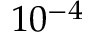<formula> <loc_0><loc_0><loc_500><loc_500>1 0 ^ { - 4 }</formula> 